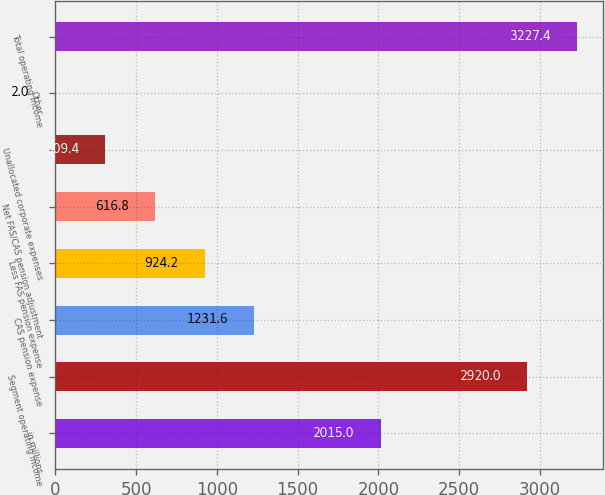Convert chart. <chart><loc_0><loc_0><loc_500><loc_500><bar_chart><fcel>in millions<fcel>Segment operating income<fcel>CAS pension expense<fcel>Less FAS pension expense<fcel>Net FAS/CAS pension adjustment<fcel>Unallocated corporate expenses<fcel>Other<fcel>Total operating income<nl><fcel>2015<fcel>2920<fcel>1231.6<fcel>924.2<fcel>616.8<fcel>309.4<fcel>2<fcel>3227.4<nl></chart> 